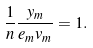Convert formula to latex. <formula><loc_0><loc_0><loc_500><loc_500>\frac { 1 } { n } \frac { y _ { m } } { e _ { m } v _ { m } } = 1 .</formula> 